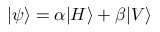<formula> <loc_0><loc_0><loc_500><loc_500>| \psi \rangle = \alpha | H \rangle + \beta | V \rangle</formula> 